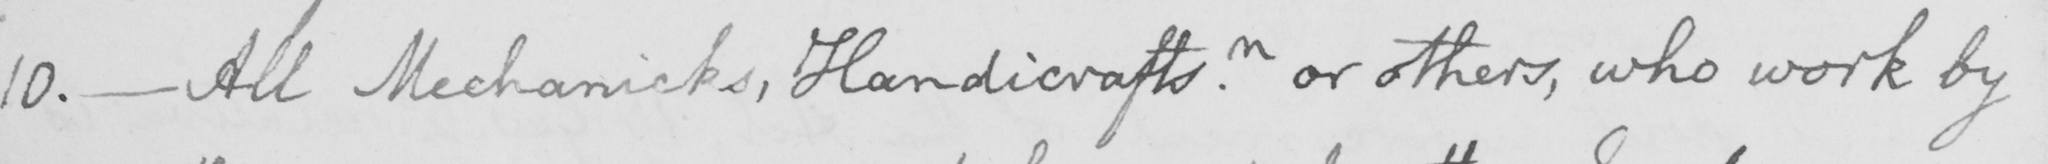Please transcribe the handwritten text in this image. 10 .  _  All Mechanicks , Handicraftsn . or others , who work by 